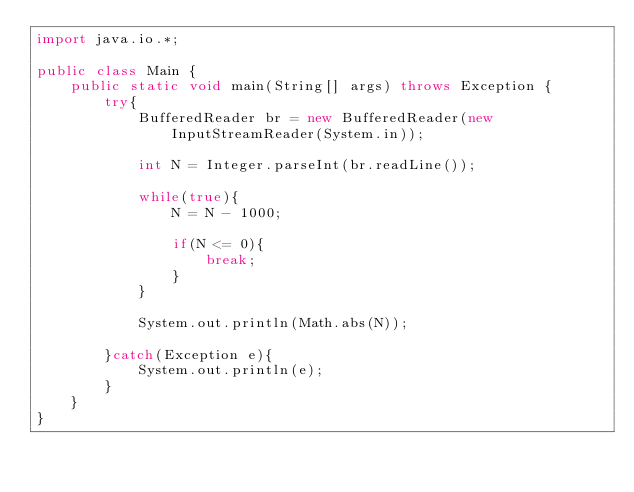Convert code to text. <code><loc_0><loc_0><loc_500><loc_500><_Java_>import java.io.*;

public class Main {
    public static void main(String[] args) throws Exception {
        try{
            BufferedReader br = new BufferedReader(new InputStreamReader(System.in));
            
            int N = Integer.parseInt(br.readLine());
            
            while(true){
                N = N - 1000;
                
                if(N <= 0){
                    break;
                }
            }
            
            System.out.println(Math.abs(N));
            
        }catch(Exception e){
            System.out.println(e);
        }
    }
}</code> 